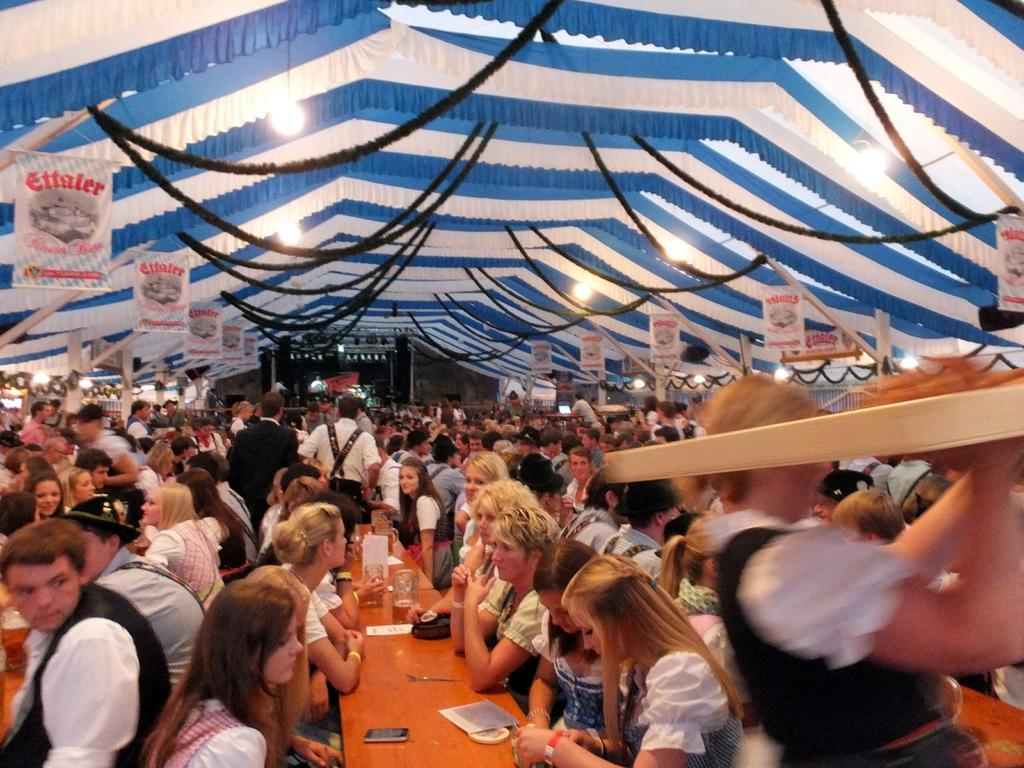Who or what can be seen in the image? There are people in the image. What objects are on the tables in the image? There are glasses and other objects on the tables. What type of structures are visible in the image? There are ropes, lights, a tent, and poles visible in the image. How many ladybugs can be seen on the tent in the image? There are no ladybugs present in the image; only people, glasses, objects on tables, ropes, lights, a tent, and poles are visible. 